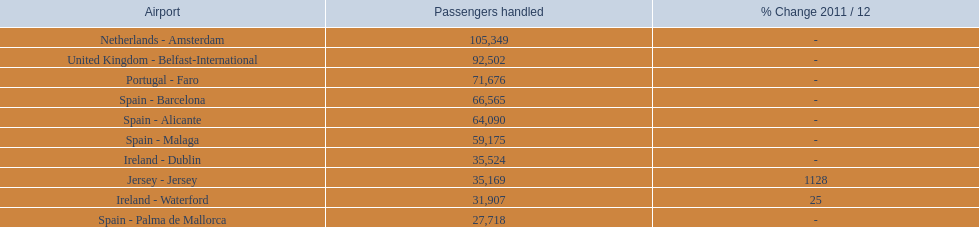What are all of the destinations out of the london southend airport? Netherlands - Amsterdam, United Kingdom - Belfast-International, Portugal - Faro, Spain - Barcelona, Spain - Alicante, Spain - Malaga, Ireland - Dublin, Jersey - Jersey, Ireland - Waterford, Spain - Palma de Mallorca. How many passengers has each destination handled? 105,349, 92,502, 71,676, 66,565, 64,090, 59,175, 35,524, 35,169, 31,907, 27,718. And of those, which airport handled the fewest passengers? Spain - Palma de Mallorca. Parse the table in full. {'header': ['Airport', 'Passengers handled', '% Change 2011 / 12'], 'rows': [['Netherlands - Amsterdam', '105,349', '-'], ['United Kingdom - Belfast-International', '92,502', '-'], ['Portugal - Faro', '71,676', '-'], ['Spain - Barcelona', '66,565', '-'], ['Spain - Alicante', '64,090', '-'], ['Spain - Malaga', '59,175', '-'], ['Ireland - Dublin', '35,524', '-'], ['Jersey - Jersey', '35,169', '1128'], ['Ireland - Waterford', '31,907', '25'], ['Spain - Palma de Mallorca', '27,718', '-']]} 